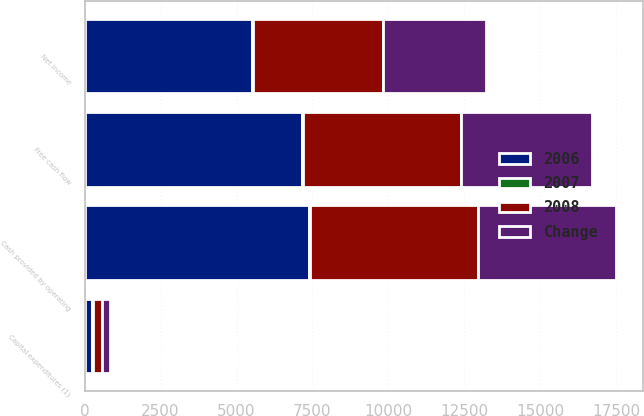Convert chart to OTSL. <chart><loc_0><loc_0><loc_500><loc_500><stacked_bar_chart><ecel><fcel>Cash provided by operating<fcel>Capital expenditures (1)<fcel>Free cash flow<fcel>Net income<nl><fcel>2006<fcel>7402<fcel>243<fcel>7159<fcel>5521<nl><fcel>2007<fcel>34<fcel>24<fcel>38<fcel>29<nl><fcel>2008<fcel>5520<fcel>319<fcel>5201<fcel>4274<nl><fcel>Change<fcel>4541<fcel>236<fcel>4305<fcel>3381<nl></chart> 